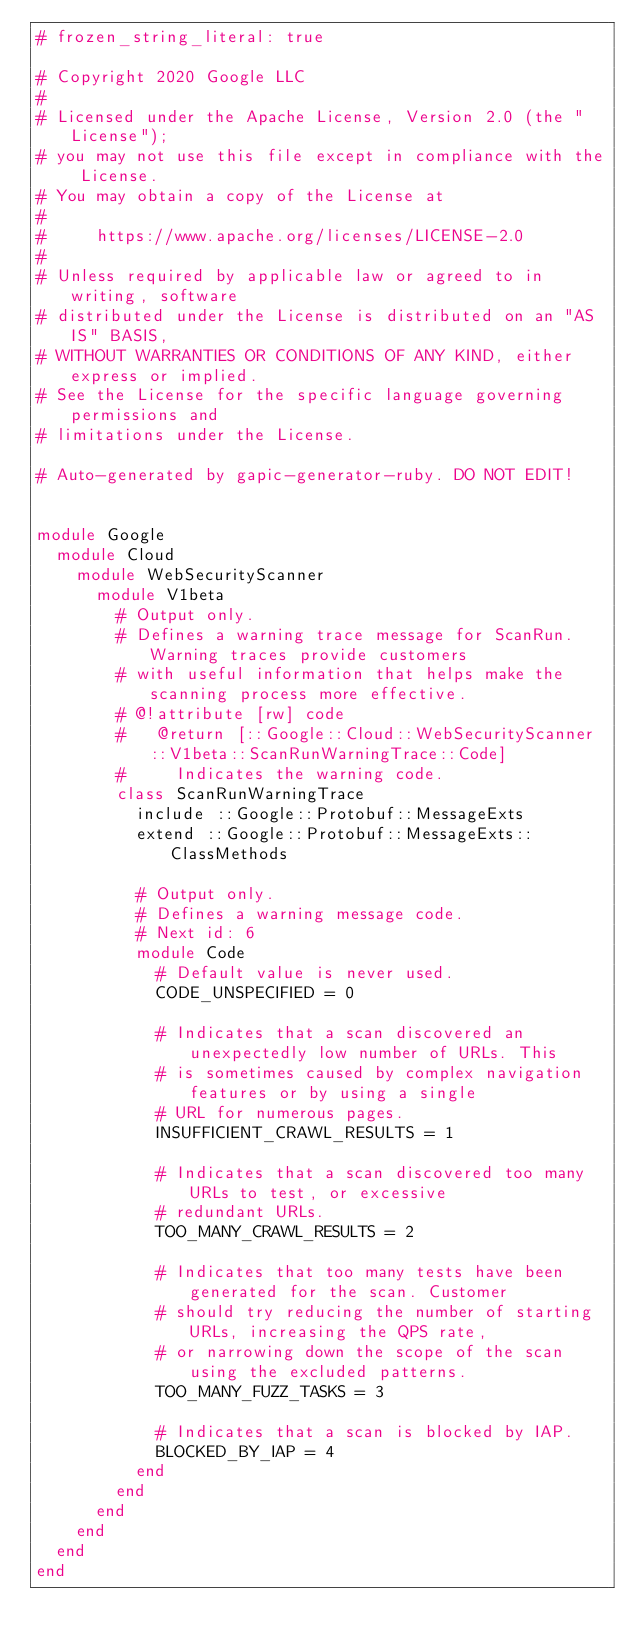<code> <loc_0><loc_0><loc_500><loc_500><_Ruby_># frozen_string_literal: true

# Copyright 2020 Google LLC
#
# Licensed under the Apache License, Version 2.0 (the "License");
# you may not use this file except in compliance with the License.
# You may obtain a copy of the License at
#
#     https://www.apache.org/licenses/LICENSE-2.0
#
# Unless required by applicable law or agreed to in writing, software
# distributed under the License is distributed on an "AS IS" BASIS,
# WITHOUT WARRANTIES OR CONDITIONS OF ANY KIND, either express or implied.
# See the License for the specific language governing permissions and
# limitations under the License.

# Auto-generated by gapic-generator-ruby. DO NOT EDIT!


module Google
  module Cloud
    module WebSecurityScanner
      module V1beta
        # Output only.
        # Defines a warning trace message for ScanRun. Warning traces provide customers
        # with useful information that helps make the scanning process more effective.
        # @!attribute [rw] code
        #   @return [::Google::Cloud::WebSecurityScanner::V1beta::ScanRunWarningTrace::Code]
        #     Indicates the warning code.
        class ScanRunWarningTrace
          include ::Google::Protobuf::MessageExts
          extend ::Google::Protobuf::MessageExts::ClassMethods

          # Output only.
          # Defines a warning message code.
          # Next id: 6
          module Code
            # Default value is never used.
            CODE_UNSPECIFIED = 0

            # Indicates that a scan discovered an unexpectedly low number of URLs. This
            # is sometimes caused by complex navigation features or by using a single
            # URL for numerous pages.
            INSUFFICIENT_CRAWL_RESULTS = 1

            # Indicates that a scan discovered too many URLs to test, or excessive
            # redundant URLs.
            TOO_MANY_CRAWL_RESULTS = 2

            # Indicates that too many tests have been generated for the scan. Customer
            # should try reducing the number of starting URLs, increasing the QPS rate,
            # or narrowing down the scope of the scan using the excluded patterns.
            TOO_MANY_FUZZ_TASKS = 3

            # Indicates that a scan is blocked by IAP.
            BLOCKED_BY_IAP = 4
          end
        end
      end
    end
  end
end
</code> 